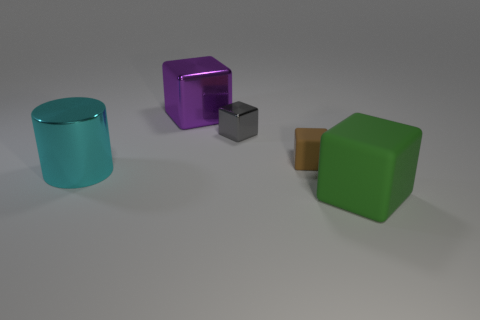There is a matte block that is to the left of the green object; does it have the same size as the shiny object that is to the right of the big purple object?
Ensure brevity in your answer.  Yes. What size is the purple thing that is the same material as the big cyan thing?
Offer a very short reply. Large. What number of things are both to the right of the purple block and in front of the tiny brown rubber cube?
Provide a succinct answer. 1. How many things are either small matte balls or big metal objects that are in front of the purple block?
Give a very brief answer. 1. What color is the rubber thing that is behind the large matte cube?
Offer a very short reply. Brown. How many things are matte objects in front of the metal cylinder or big matte things?
Provide a succinct answer. 1. The rubber object that is the same size as the gray cube is what color?
Your response must be concise. Brown. Are there more big matte cubes that are in front of the big metal cube than big gray matte blocks?
Provide a short and direct response. Yes. What is the block that is both to the right of the tiny gray metallic thing and behind the large cyan cylinder made of?
Your response must be concise. Rubber. How many other objects are there of the same size as the purple metal thing?
Offer a terse response. 2. 